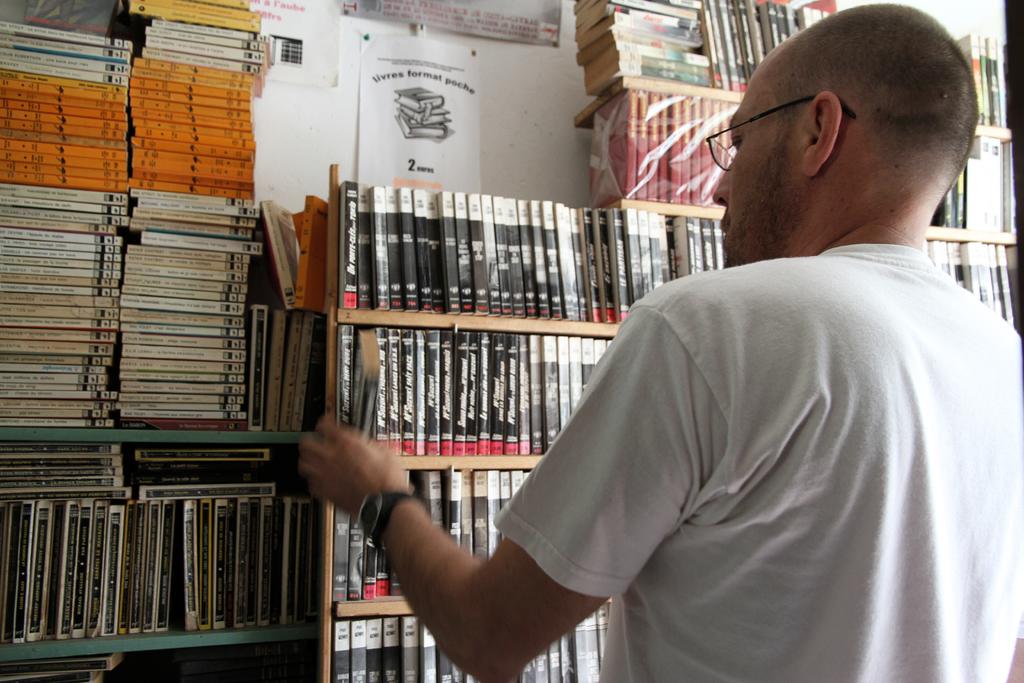What does it say at the bottom of the paper on the wall?
Provide a short and direct response. 2. 